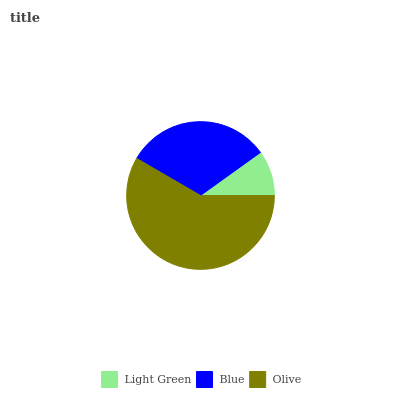Is Light Green the minimum?
Answer yes or no. Yes. Is Olive the maximum?
Answer yes or no. Yes. Is Blue the minimum?
Answer yes or no. No. Is Blue the maximum?
Answer yes or no. No. Is Blue greater than Light Green?
Answer yes or no. Yes. Is Light Green less than Blue?
Answer yes or no. Yes. Is Light Green greater than Blue?
Answer yes or no. No. Is Blue less than Light Green?
Answer yes or no. No. Is Blue the high median?
Answer yes or no. Yes. Is Blue the low median?
Answer yes or no. Yes. Is Olive the high median?
Answer yes or no. No. Is Olive the low median?
Answer yes or no. No. 